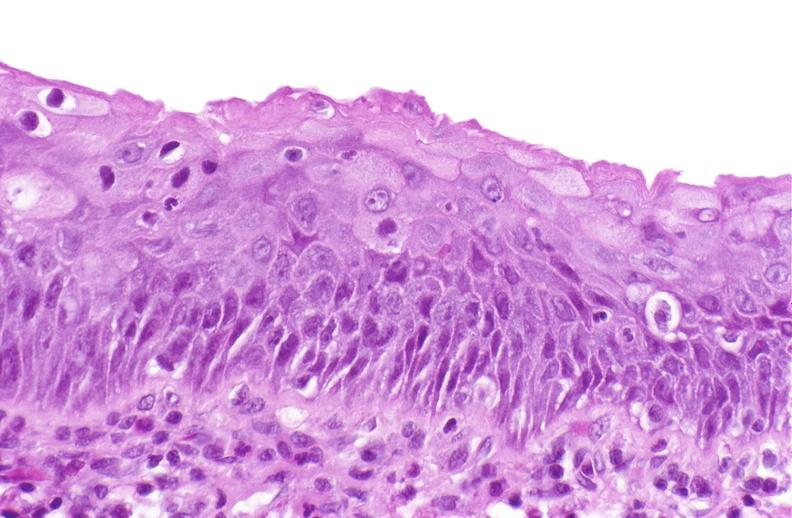s gastrointestinal present?
Answer the question using a single word or phrase. No 